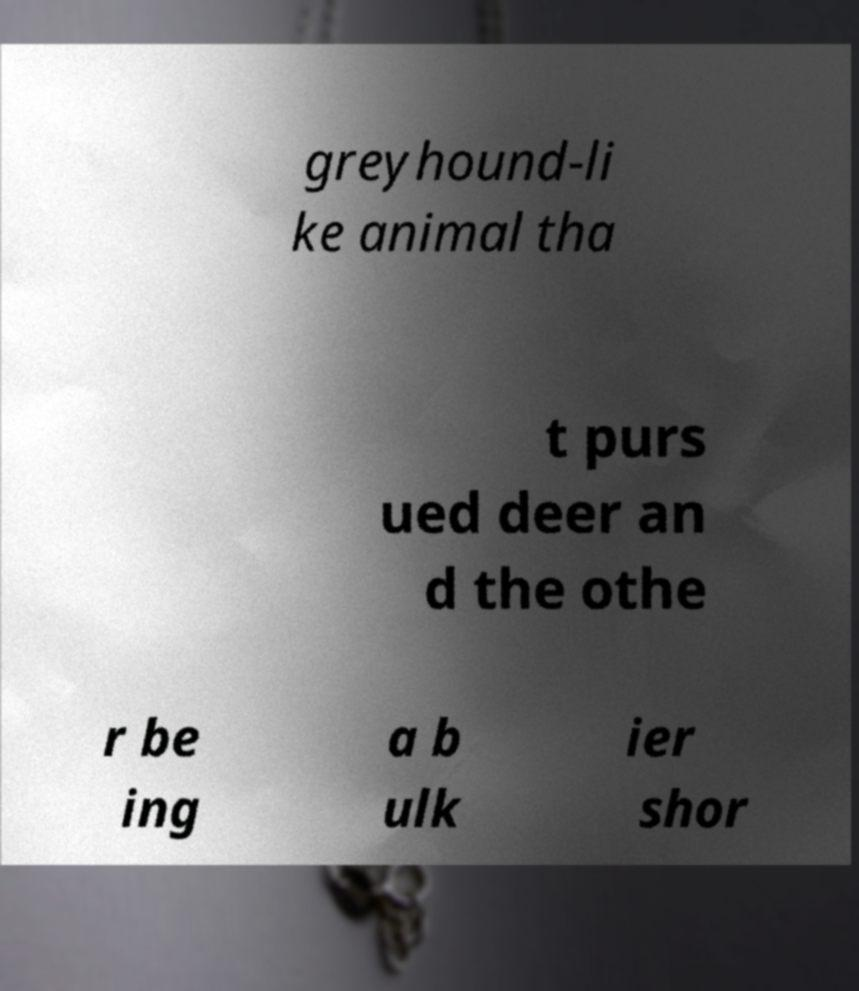I need the written content from this picture converted into text. Can you do that? greyhound-li ke animal tha t purs ued deer an d the othe r be ing a b ulk ier shor 